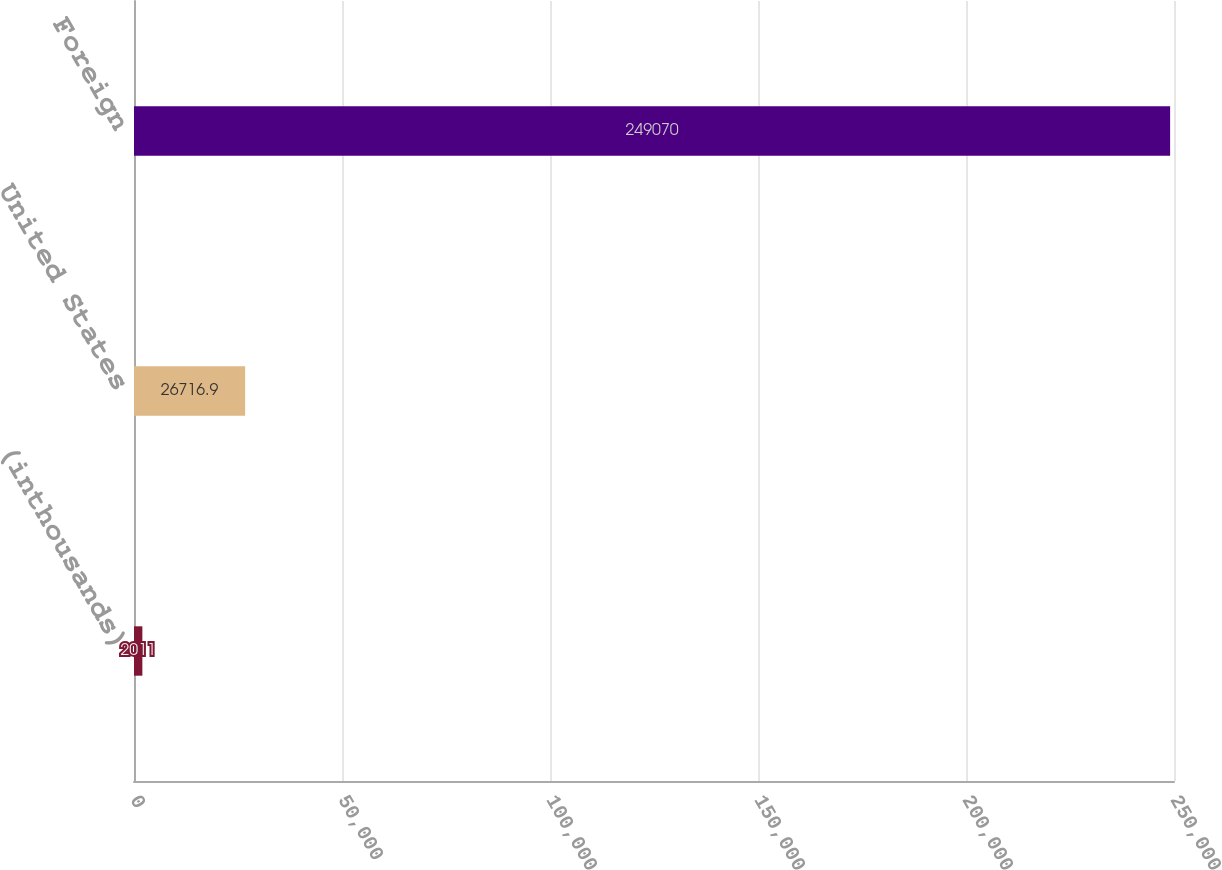Convert chart. <chart><loc_0><loc_0><loc_500><loc_500><bar_chart><fcel>(inthousands)<fcel>United States<fcel>Foreign<nl><fcel>2011<fcel>26716.9<fcel>249070<nl></chart> 